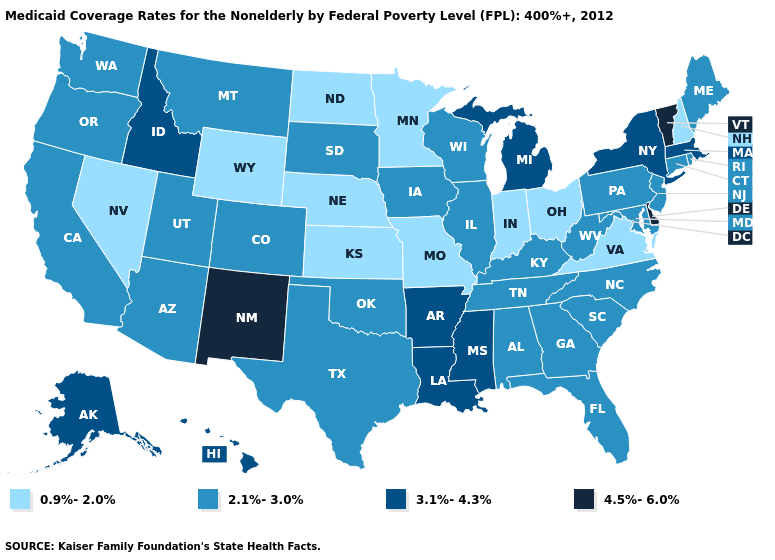What is the value of South Dakota?
Quick response, please. 2.1%-3.0%. What is the value of Minnesota?
Quick response, please. 0.9%-2.0%. How many symbols are there in the legend?
Concise answer only. 4. What is the lowest value in states that border Delaware?
Quick response, please. 2.1%-3.0%. Does Texas have the same value as Washington?
Concise answer only. Yes. Name the states that have a value in the range 3.1%-4.3%?
Write a very short answer. Alaska, Arkansas, Hawaii, Idaho, Louisiana, Massachusetts, Michigan, Mississippi, New York. What is the lowest value in the USA?
Give a very brief answer. 0.9%-2.0%. What is the value of Missouri?
Short answer required. 0.9%-2.0%. What is the value of Michigan?
Give a very brief answer. 3.1%-4.3%. What is the highest value in the USA?
Short answer required. 4.5%-6.0%. Does Ohio have the lowest value in the USA?
Concise answer only. Yes. Does Maryland have the same value as New Jersey?
Short answer required. Yes. What is the highest value in states that border Nevada?
Be succinct. 3.1%-4.3%. Does the first symbol in the legend represent the smallest category?
Give a very brief answer. Yes. What is the value of Maine?
Write a very short answer. 2.1%-3.0%. 